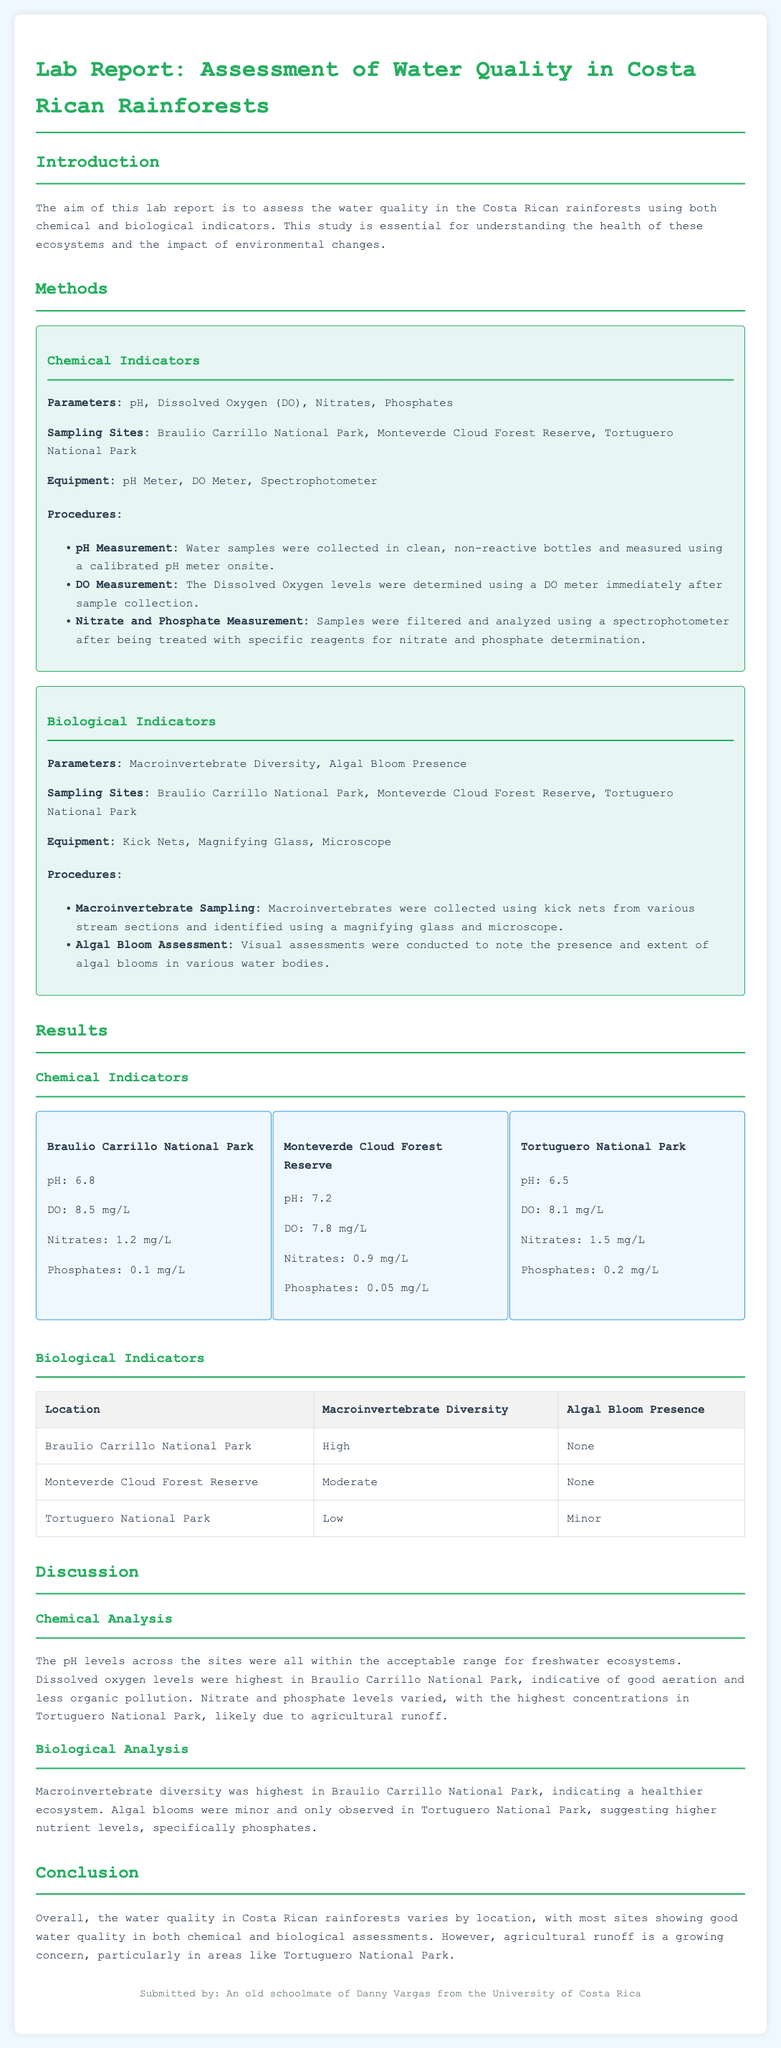what is the pH level in Monteverde Cloud Forest Reserve? The pH level is directly quoted from the results section of the report which shows the chemical indicators.
Answer: 7.2 what equipment was used for measuring Dissolved Oxygen? This information is found in the methods section where the equipment for each test is listed.
Answer: DO Meter which national park showed the highest macroinvertebrate diversity? This can be found in the biological indicators results table which compares various locations.
Answer: Braulio Carrillo National Park what were the nitrate levels in Tortuguero National Park? The nitrate levels are detailed in the results section under chemical indicators for each national park.
Answer: 1.5 mg/L what was noted about algal blooms in Monteverde Cloud Forest Reserve? This was stated directly in the biological analysis section, highlighting presence or absence.
Answer: None how many sampling sites were mentioned in the report? The number of sites is indicated in the methods section under both chemical and biological indicators.
Answer: Three what is the main concern highlighted in the conclusion regarding water quality? The conclusion section discusses concerns that have been raised based on the findings throughout the report.
Answer: Agricultural runoff what method was used for the nitrate and phosphate measurement? The method used for these measurements is specifically outlined in the procedures under chemical indicators.
Answer: Spectrophotometer 